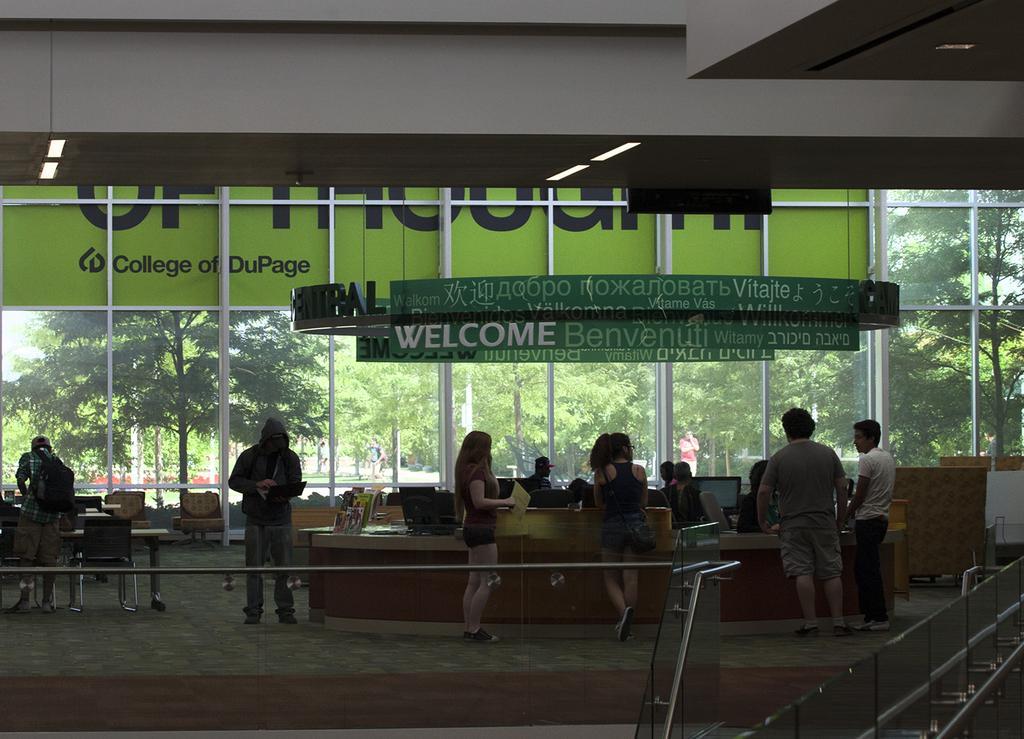Please provide a concise description of this image. This is inside view picture of a building. outside we can see trees and few persons walking on the road. This is a reception , here we can see few monitors and around this few persons are standing. Here we can see a chair and a table and also a man standing wearing a backpack. This is a hoarding. This is a welcome note. 